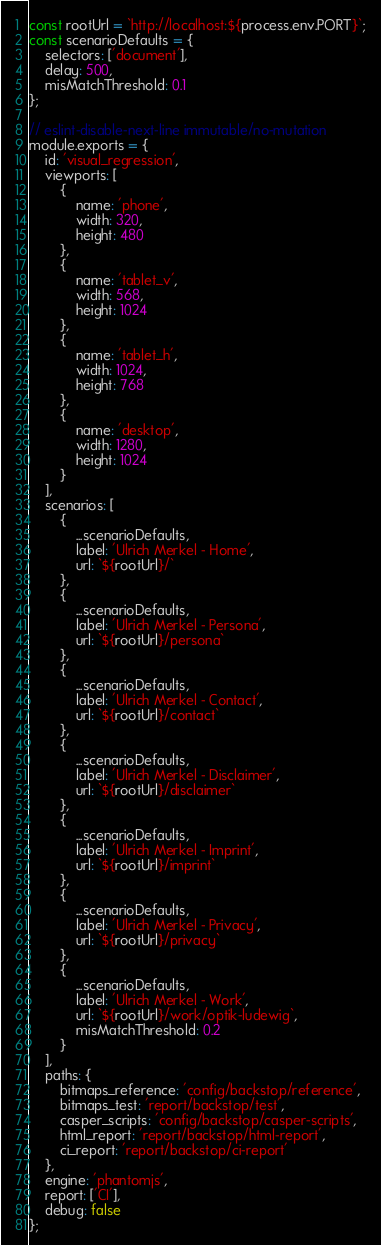<code> <loc_0><loc_0><loc_500><loc_500><_JavaScript_>const rootUrl = `http://localhost:${process.env.PORT}`;
const scenarioDefaults = {
    selectors: ['document'],
    delay: 500,
    misMatchThreshold: 0.1
};

// eslint-disable-next-line immutable/no-mutation
module.exports = {
    id: 'visual_regression',
    viewports: [
        {
            name: 'phone',
            width: 320,
            height: 480
        },
        {
            name: 'tablet_v',
            width: 568,
            height: 1024
        },
        {
            name: 'tablet_h',
            width: 1024,
            height: 768
        },
        {
            name: 'desktop',
            width: 1280,
            height: 1024
        }
    ],
    scenarios: [
        {
            ...scenarioDefaults,
            label: 'Ulrich Merkel - Home',
            url: `${rootUrl}/`
        },
        {
            ...scenarioDefaults,
            label: 'Ulrich Merkel - Persona',
            url: `${rootUrl}/persona`
        },
        {
            ...scenarioDefaults,
            label: 'Ulrich Merkel - Contact',
            url: `${rootUrl}/contact`
        },
        {
            ...scenarioDefaults,
            label: 'Ulrich Merkel - Disclaimer',
            url: `${rootUrl}/disclaimer`
        },
        {
            ...scenarioDefaults,
            label: 'Ulrich Merkel - Imprint',
            url: `${rootUrl}/imprint`
        },
        {
            ...scenarioDefaults,
            label: 'Ulrich Merkel - Privacy',
            url: `${rootUrl}/privacy`
        },
        {
            ...scenarioDefaults,
            label: 'Ulrich Merkel - Work',
            url: `${rootUrl}/work/optik-ludewig`,
            misMatchThreshold: 0.2
        }
    ],
    paths: {
        bitmaps_reference: 'config/backstop/reference',
        bitmaps_test: 'report/backstop/test',
        casper_scripts: 'config/backstop/casper-scripts',
        html_report: 'report/backstop/html-report',
        ci_report: 'report/backstop/ci-report'
    },
    engine: 'phantomjs',
    report: ['CI'],
    debug: false
};
</code> 